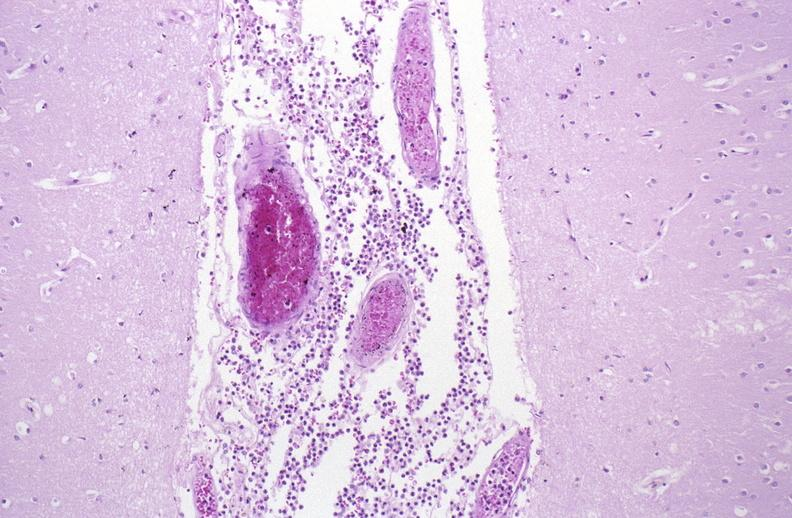does metastatic carcinoma show bacterial meningitis?
Answer the question using a single word or phrase. No 